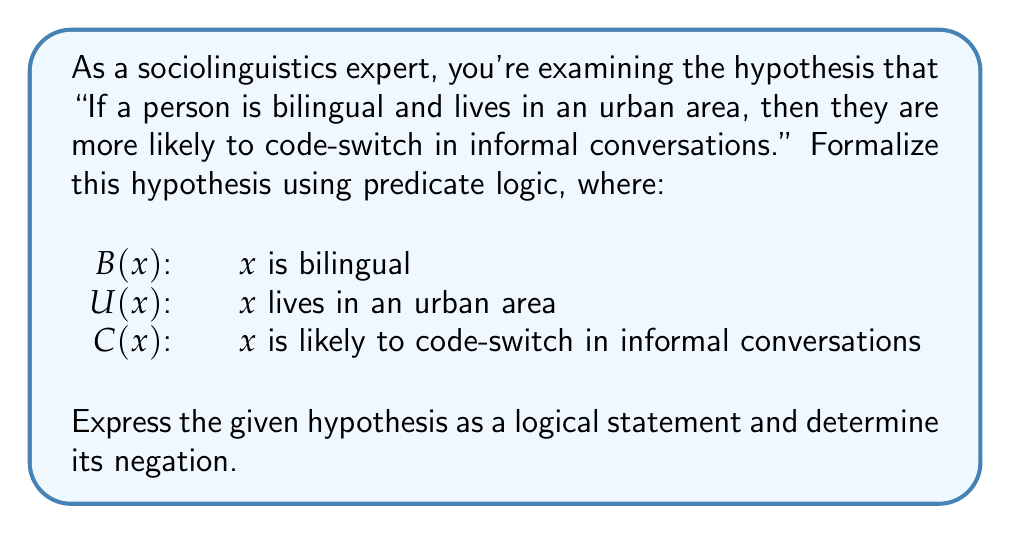Can you solve this math problem? Let's approach this step-by-step:

1) First, we need to formalize the hypothesis using predicate logic:

   $\forall x ((B(x) \land U(x)) \rightarrow C(x))$

   This reads as "For all x, if x is bilingual and x lives in an urban area, then x is likely to code-switch in informal conversations."

2) To negate this statement, we need to apply the rules of logical negation:
   - The negation of a universal quantifier ($\forall$) is an existential quantifier ($\exists$)
   - The negation of an implication ($P \rightarrow Q$) is ($P \land \neg Q$)

3) Applying these rules, we get:

   $\neg(\forall x ((B(x) \land U(x)) \rightarrow C(x)))$
   $\equiv \exists x \neg((B(x) \land U(x)) \rightarrow C(x))$
   $\equiv \exists x ((B(x) \land U(x)) \land \neg C(x))$

4) This negation can be read as "There exists an x such that x is bilingual and x lives in an urban area, but x is not likely to code-switch in informal conversations."

This negation provides a way to test the original hypothesis. If we can find even one person who is bilingual, lives in an urban area, but does not tend to code-switch in informal conversations, it would disprove the original hypothesis.
Answer: $\exists x ((B(x) \land U(x)) \land \neg C(x))$ 